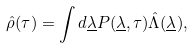Convert formula to latex. <formula><loc_0><loc_0><loc_500><loc_500>\hat { \rho } ( \tau ) = \int d \underline { \lambda } P ( \underline { \lambda } , \tau ) \hat { \Lambda } ( \underline { \lambda } ) ,</formula> 